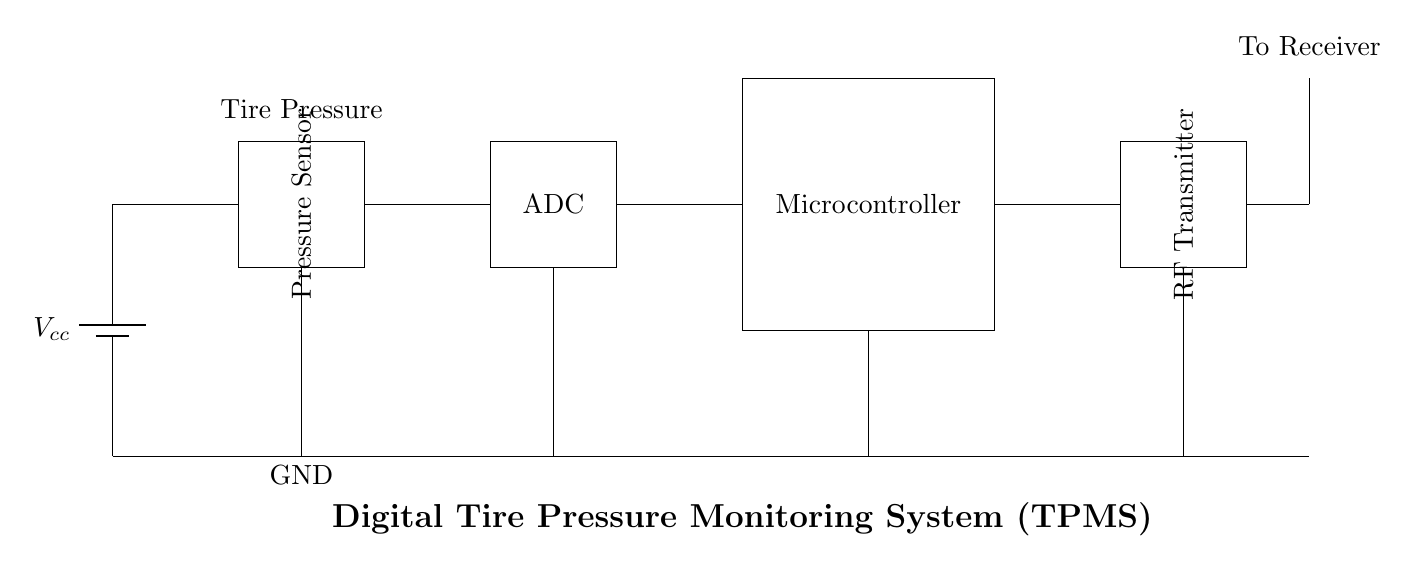What is the primary function of the pressure sensor? The primary function of the pressure sensor is to measure tire pressure, as indicated by the label on the component in the diagram.
Answer: Measure tire pressure How many main components are there in the circuit? There are five main components: the pressure sensor, ADC, microcontroller, RF transmitter, and the antenna, which are all visually identifiable in the circuit.
Answer: Five What type of signal does the RF transmitter convert? The RF transmitter converts the digital signal from the microcontroller into radio waves for transmission, evident from its placement after the microcontroller in the flow of information.
Answer: Digital signal What is the role of the ADC in this circuit? The ADC (Analog-to-Digital Converter) converts the analog signal from the pressure sensor into a digital signal for processing by the microcontroller, based on its position in the circuit's data path.
Answer: Converts analog to digital What is connected to the antenna? The antenna is connected to the RF transmitter, shown by the line drawn from the RF transmitter to the antenna, indicating that it transmits signals.
Answer: RF transmitter Which component is powered by the battery? The battery powers all components in this circuit, as indicated by the connections leading from the power supply to each of the main components.
Answer: All components 